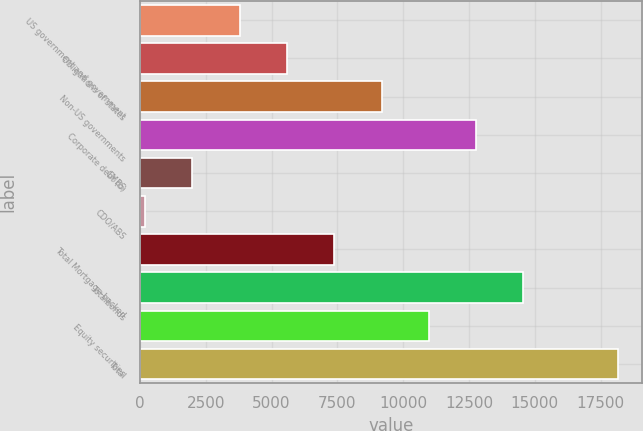Convert chart to OTSL. <chart><loc_0><loc_0><loc_500><loc_500><bar_chart><fcel>US government and government<fcel>Obligations of states<fcel>Non-US governments<fcel>Corporate debt (b)<fcel>CMBS<fcel>CDO/ABS<fcel>Total Mortgage-backed<fcel>Totalbonds<fcel>Equity securities<fcel>Total<nl><fcel>3789.4<fcel>5586.1<fcel>9179.5<fcel>12772.9<fcel>1992.7<fcel>196<fcel>7382.8<fcel>14569.6<fcel>10976.2<fcel>18163<nl></chart> 